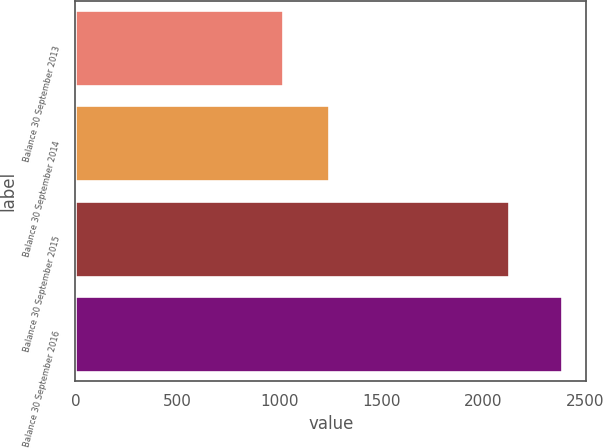Convert chart. <chart><loc_0><loc_0><loc_500><loc_500><bar_chart><fcel>Balance 30 September 2013<fcel>Balance 30 September 2014<fcel>Balance 30 September 2015<fcel>Balance 30 September 2016<nl><fcel>1020.6<fcel>1241.9<fcel>2125.9<fcel>2388.3<nl></chart> 